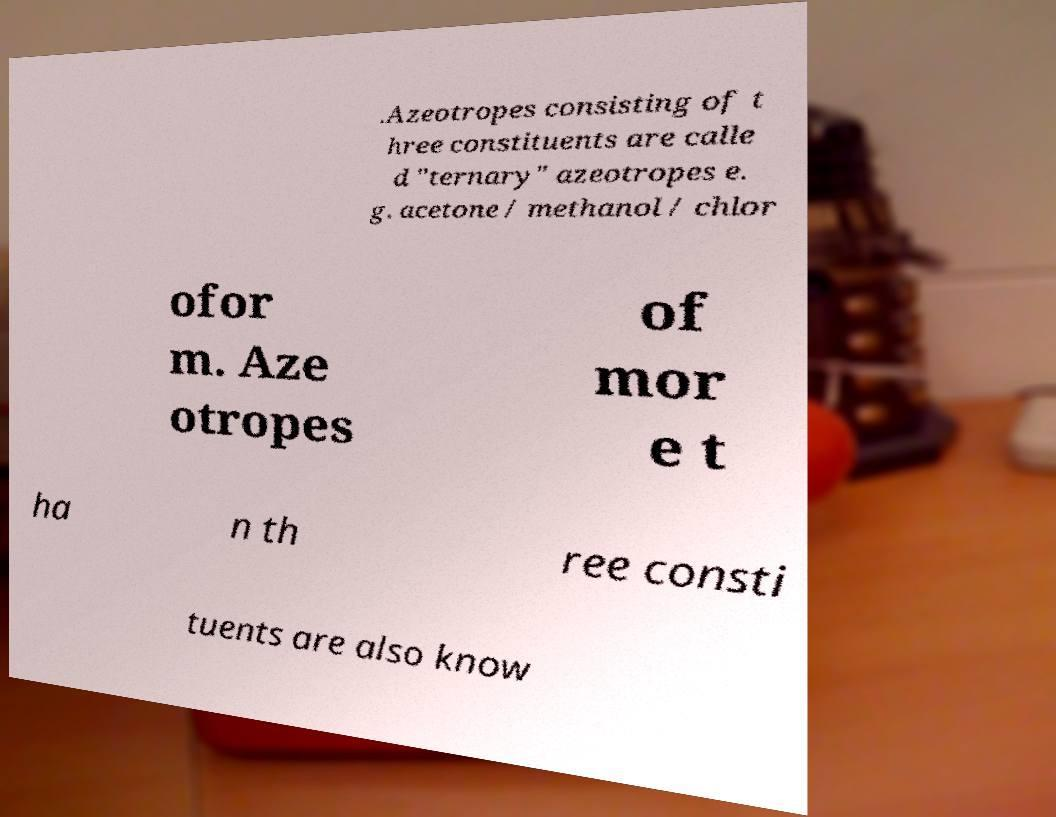I need the written content from this picture converted into text. Can you do that? .Azeotropes consisting of t hree constituents are calle d "ternary" azeotropes e. g. acetone / methanol / chlor ofor m. Aze otropes of mor e t ha n th ree consti tuents are also know 